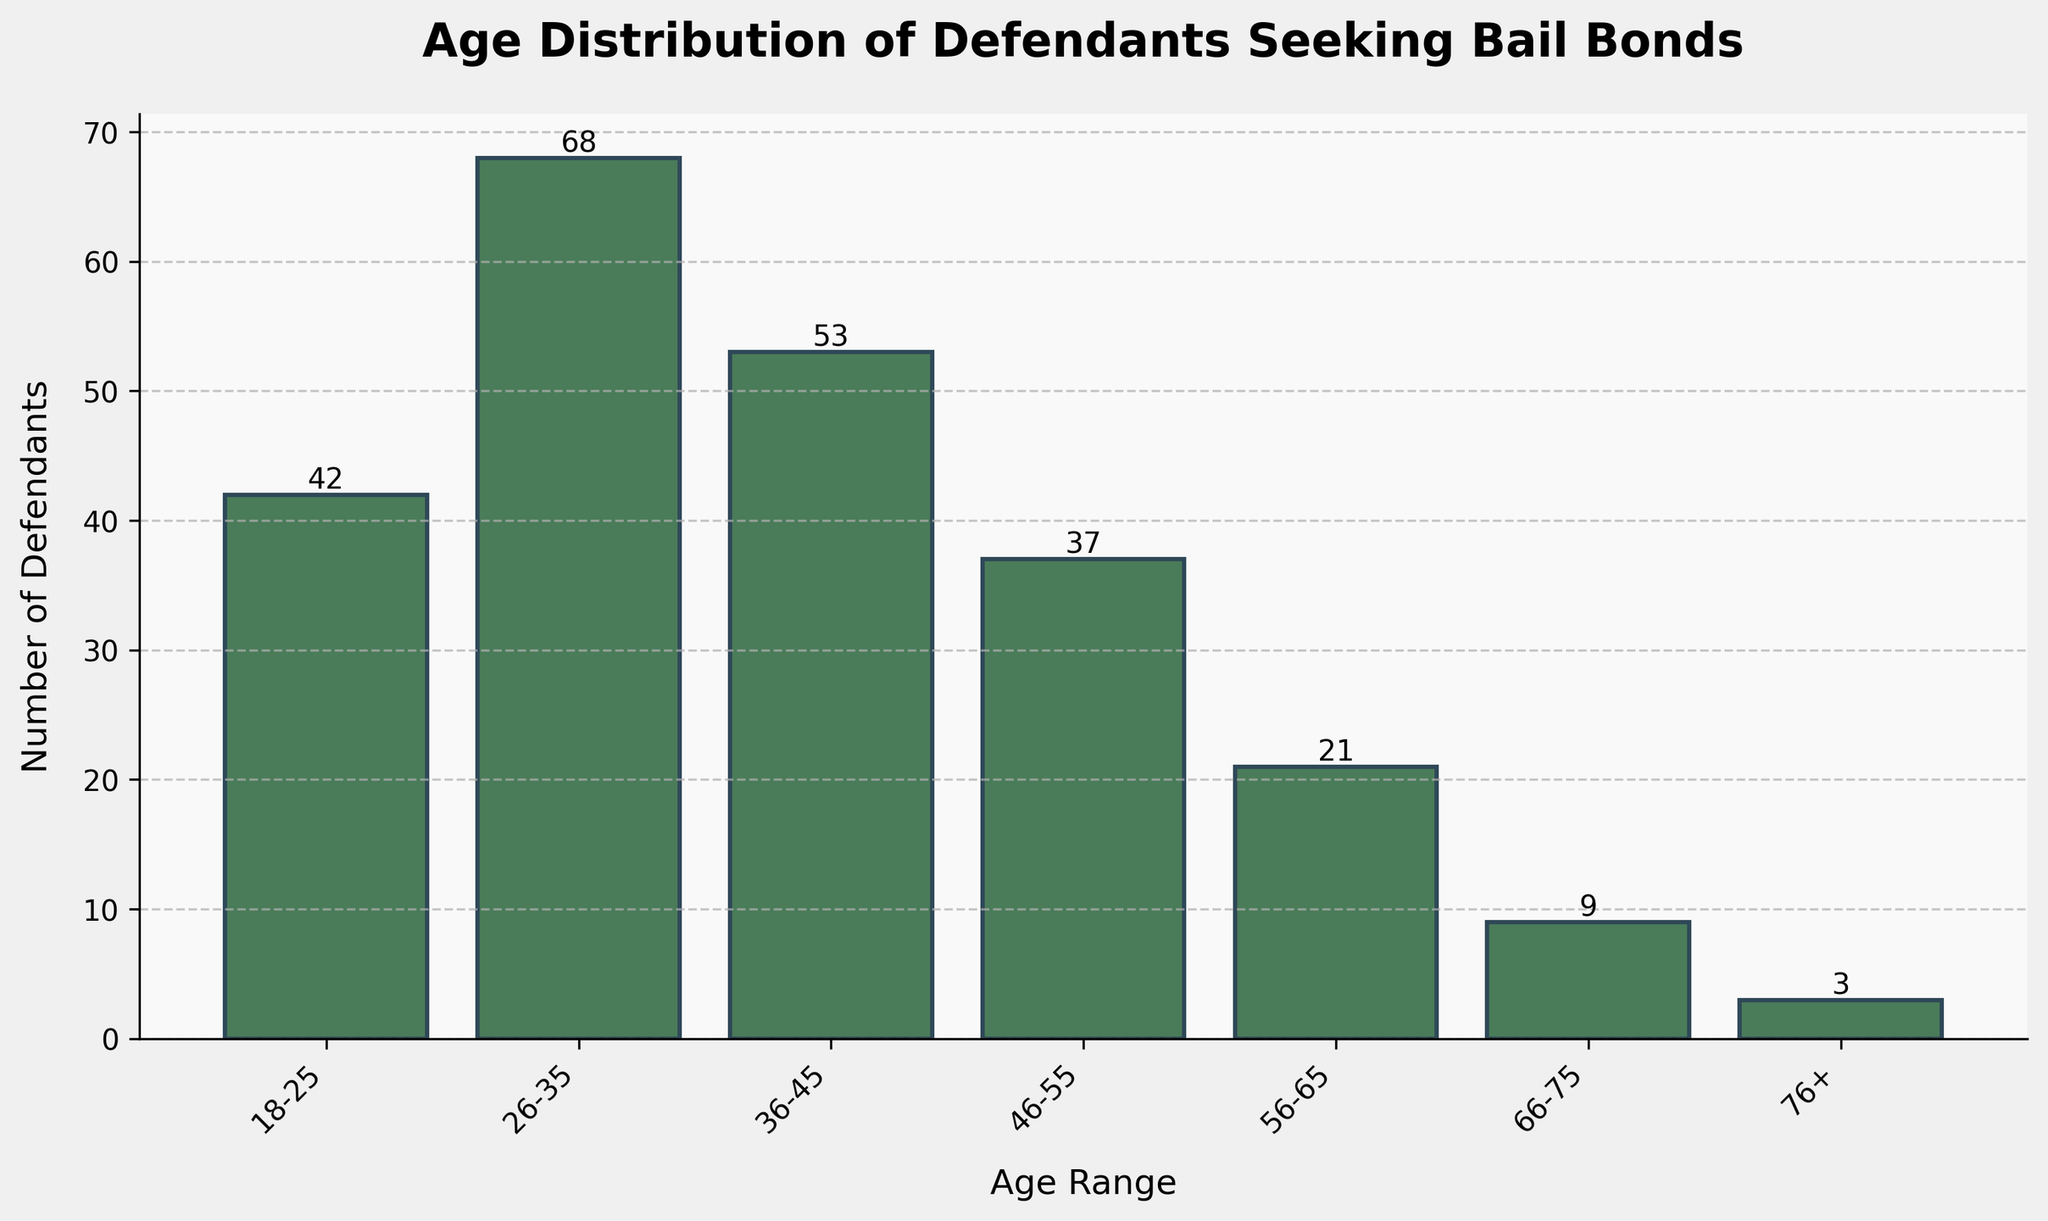What's the title of the figure? The title is often located at the top of the figure. Here, it is clearly written in a bold font at the top center of the plot.
Answer: Age Distribution of Defendants Seeking Bail Bonds What is the age range with the highest number of defendants? By looking at the height of each bar, the tallest bar represents the age range with the most defendants. The bar for the 26-35 age range is the highest.
Answer: 26-35 How many defendants are in the 56-65 age range? Each bar represents an age range, and its height indicates the number of defendants. Referring to the bar labeled 56-65, we can see the numerical label above it.
Answer: 21 Which age range has the smallest number of defendants? The smallest bar indicates the age range with the fewest defendants. The bar labeled 76+ is the shortest.
Answer: 76+ Calculate the total number of defendants across all age ranges. Sum the counts of defendants from each age range: 42 + 68 + 53 + 37 + 21 + 9 + 3.
Answer: 233 How many more defendants are there in the 26-35 age range compared to the 66-75 age range? Subtract the number of defendants in the 66-75 age range from the number in the 26-35 age range: 68 - 9.
Answer: 59 Compare the number of defendants in the 36-45 age range with those in the 46-55 age range. Which is greater? Look at the bars for both the 36-45 and 46-55 age ranges. The height of the 36-45 bar is greater.
Answer: 36-45 What is the combined total number of defendants for the age ranges under 36 years old? Add the number of defendants in the 18-25 and 26-35 age ranges: 42 + 68.
Answer: 110 How does the number of defendants in the 46-55 age range compare to the 18-25 age range? Compare the heights of the bars for these age ranges. The bar for 18-25 is taller.
Answer: 18-25 Is there a significant drop in the number of defendants after the 55-65 age range? Compare the bars for the 55-65 and the 66-75 age ranges. The number drops from 21 to 9, which indicates a significant decrease.
Answer: Yes 